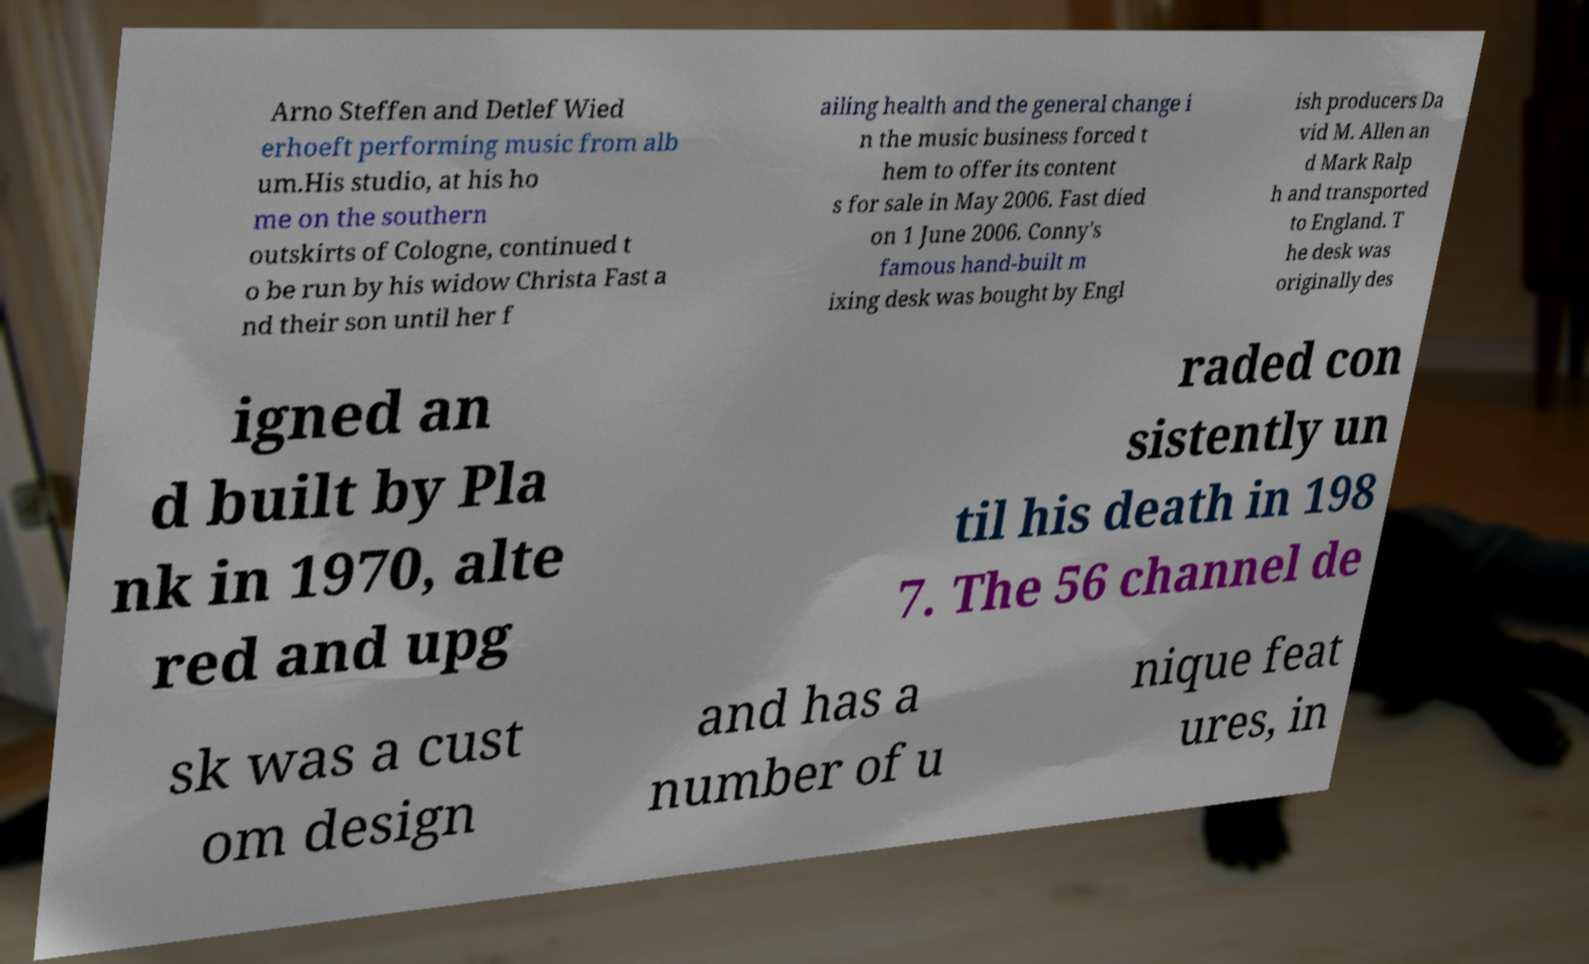Could you extract and type out the text from this image? Arno Steffen and Detlef Wied erhoeft performing music from alb um.His studio, at his ho me on the southern outskirts of Cologne, continued t o be run by his widow Christa Fast a nd their son until her f ailing health and the general change i n the music business forced t hem to offer its content s for sale in May 2006. Fast died on 1 June 2006. Conny's famous hand-built m ixing desk was bought by Engl ish producers Da vid M. Allen an d Mark Ralp h and transported to England. T he desk was originally des igned an d built by Pla nk in 1970, alte red and upg raded con sistently un til his death in 198 7. The 56 channel de sk was a cust om design and has a number of u nique feat ures, in 